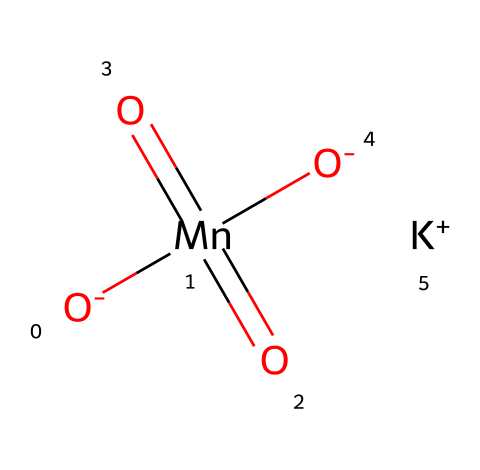What is the chemical name of this compound? The SMILES representation includes the elements present: Potassium (K), Manganese (Mn), and Oxygen (O). This combination corresponds to potassium permanganate, a well-known oxidizer.
Answer: potassium permanganate How many oxygen atoms are present in this molecule? By analyzing the SMILES, we can see there are four oxygen atoms indicated (shown by "[O-]" and "(=O)"), confirming the total count.
Answer: four What is the oxidation state of manganese in this compound? Manganese is bound to four oxygen atoms, two of which are double-bonded and have an overall -8 charge from the two negative and four double bond contributions. The potassium balances the charge, thus manganese is in the +7 oxidation state.
Answer: +7 Which element in this compound is responsible for its oxidizing properties? The presence of the manganese atom (Mn), specifically in the +7 oxidation state, indicates a strong tendency to gain electrons, characterizing it as the oxidizer in the compound.
Answer: manganese What role does potassium play in this chemical? Potassium serves to balance charges in the compound and contributes to solubility in water, enhancing its practical application in water treatment processes.
Answer: charge balancing 